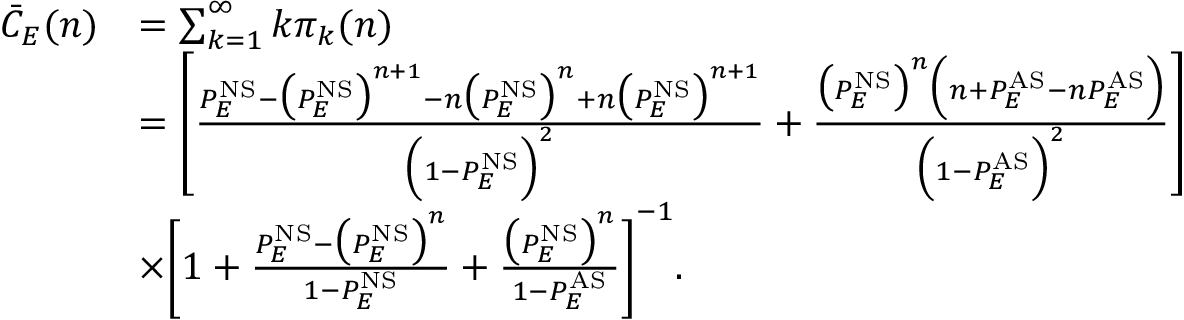<formula> <loc_0><loc_0><loc_500><loc_500>\begin{array} { r l } { \bar { C } _ { E } ( n ) } & { = \sum _ { k = 1 } ^ { \infty } k \pi _ { k } ( n ) } \\ & { = \left [ \frac { P _ { E } ^ { N S } - \left ( P _ { E } ^ { N S } \right ) ^ { n + 1 } - n \left ( P _ { E } ^ { N S } \right ) ^ { n } + n \left ( P _ { E } ^ { N S } \right ) ^ { n + 1 } } { \left ( 1 - P _ { E } ^ { N S } \right ) ^ { 2 } } + \frac { \left ( P _ { E } ^ { N S } \right ) ^ { n } \left ( n + P _ { E } ^ { A S } - n P _ { E } ^ { A S } \right ) } { \left ( 1 - P _ { E } ^ { A S } \right ) ^ { 2 } } \right ] } \\ & { \times \left [ 1 + \frac { P _ { E } ^ { N S } - \left ( P _ { E } ^ { N S } \right ) ^ { n } } { 1 - P _ { E } ^ { N S } } + \frac { \left ( P _ { E } ^ { N S } \right ) ^ { n } } { 1 - P _ { E } ^ { A S } } \right ] ^ { - 1 } . } \end{array}</formula> 